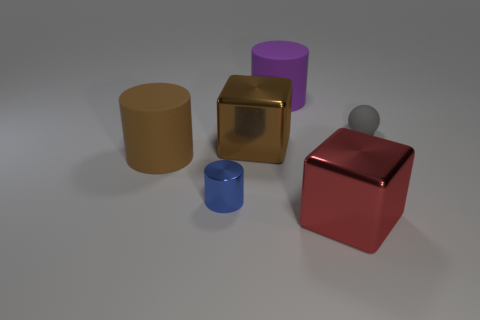What number of brown rubber things are the same size as the gray ball?
Give a very brief answer. 0. There is a shiny cube that is behind the large red metal cube; is its color the same as the tiny thing in front of the large brown cylinder?
Provide a succinct answer. No. How many blue objects are behind the large purple matte object?
Provide a short and direct response. 0. Are there any red shiny things of the same shape as the purple matte thing?
Keep it short and to the point. No. The object that is the same size as the gray matte ball is what color?
Provide a succinct answer. Blue. Is the number of large objects in front of the big red metal thing less than the number of big brown things that are left of the large brown rubber thing?
Keep it short and to the point. No. Do the block to the left of the red cube and the purple matte thing have the same size?
Ensure brevity in your answer.  Yes. What is the shape of the big rubber thing that is to the right of the small blue cylinder?
Your answer should be very brief. Cylinder. Is the number of metallic objects greater than the number of tiny purple shiny objects?
Make the answer very short. Yes. There is a rubber cylinder that is in front of the gray thing; does it have the same color as the tiny matte sphere?
Keep it short and to the point. No. 